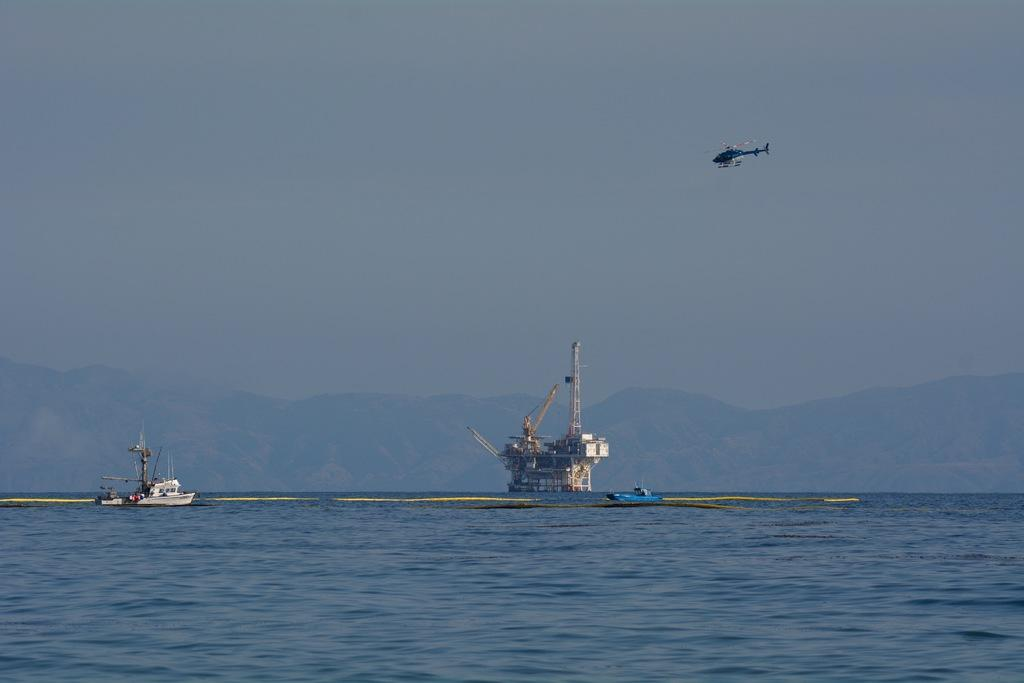What type of vehicles are present in the image? There are boats, a ship, and a helicopter in the image. Where are the boats and ship located in the image? The boats and ship are on the surface of the water in the image. What can be seen in the background of the image? Hills and the sky are visible in the background of the image. What type of farming equipment can be seen in the image? There is no farming equipment present in the image. What is the aftermath of the helicopter crash in the image? There is no helicopter crash depicted in the image; the helicopter is shown in flight. 